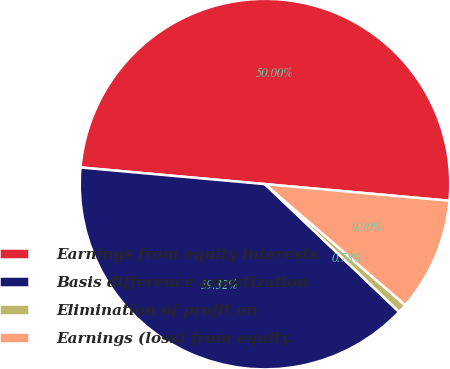Convert chart. <chart><loc_0><loc_0><loc_500><loc_500><pie_chart><fcel>Earnings from equity interests<fcel>Basis difference amortization<fcel>Elimination of profit on<fcel>Earnings (loss) from equity<nl><fcel>50.0%<fcel>39.32%<fcel>0.78%<fcel>9.9%<nl></chart> 